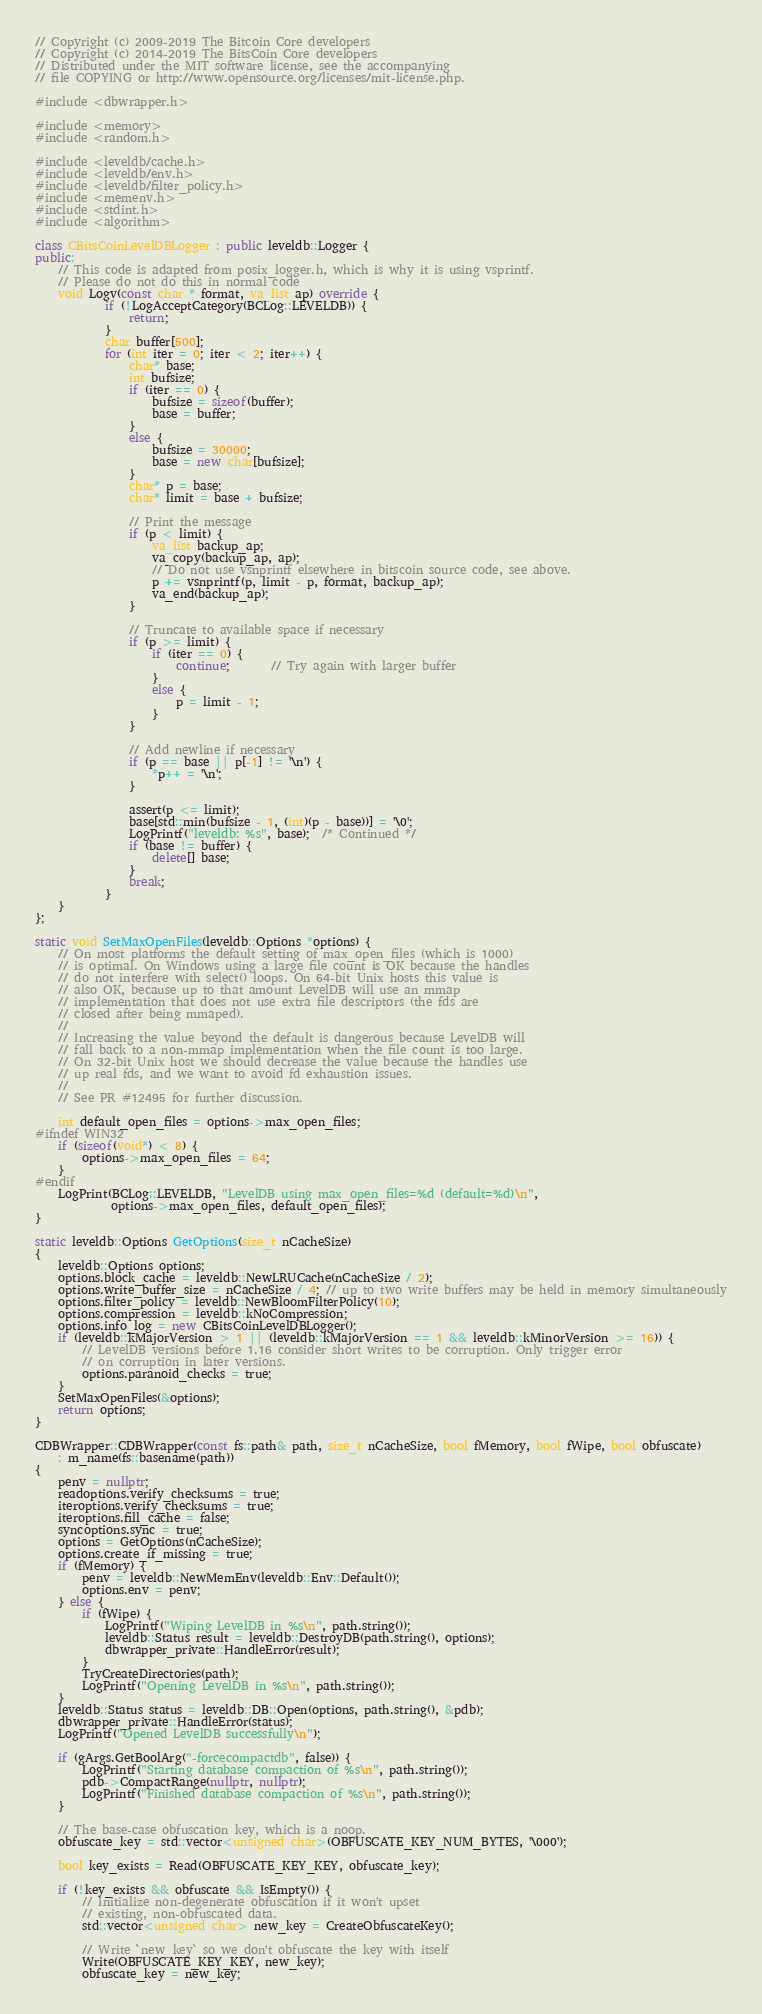Convert code to text. <code><loc_0><loc_0><loc_500><loc_500><_C++_>// Copyright (c) 2009-2019 The Bitcoin Core developers
// Copyright (c) 2014-2019 The BitsCoin Core developers
// Distributed under the MIT software license, see the accompanying
// file COPYING or http://www.opensource.org/licenses/mit-license.php.

#include <dbwrapper.h>

#include <memory>
#include <random.h>

#include <leveldb/cache.h>
#include <leveldb/env.h>
#include <leveldb/filter_policy.h>
#include <memenv.h>
#include <stdint.h>
#include <algorithm>

class CBitsCoinLevelDBLogger : public leveldb::Logger {
public:
    // This code is adapted from posix_logger.h, which is why it is using vsprintf.
    // Please do not do this in normal code
    void Logv(const char * format, va_list ap) override {
            if (!LogAcceptCategory(BCLog::LEVELDB)) {
                return;
            }
            char buffer[500];
            for (int iter = 0; iter < 2; iter++) {
                char* base;
                int bufsize;
                if (iter == 0) {
                    bufsize = sizeof(buffer);
                    base = buffer;
                }
                else {
                    bufsize = 30000;
                    base = new char[bufsize];
                }
                char* p = base;
                char* limit = base + bufsize;

                // Print the message
                if (p < limit) {
                    va_list backup_ap;
                    va_copy(backup_ap, ap);
                    // Do not use vsnprintf elsewhere in bitscoin source code, see above.
                    p += vsnprintf(p, limit - p, format, backup_ap);
                    va_end(backup_ap);
                }

                // Truncate to available space if necessary
                if (p >= limit) {
                    if (iter == 0) {
                        continue;       // Try again with larger buffer
                    }
                    else {
                        p = limit - 1;
                    }
                }

                // Add newline if necessary
                if (p == base || p[-1] != '\n') {
                    *p++ = '\n';
                }

                assert(p <= limit);
                base[std::min(bufsize - 1, (int)(p - base))] = '\0';
                LogPrintf("leveldb: %s", base);  /* Continued */
                if (base != buffer) {
                    delete[] base;
                }
                break;
            }
    }
};

static void SetMaxOpenFiles(leveldb::Options *options) {
    // On most platforms the default setting of max_open_files (which is 1000)
    // is optimal. On Windows using a large file count is OK because the handles
    // do not interfere with select() loops. On 64-bit Unix hosts this value is
    // also OK, because up to that amount LevelDB will use an mmap
    // implementation that does not use extra file descriptors (the fds are
    // closed after being mmaped).
    //
    // Increasing the value beyond the default is dangerous because LevelDB will
    // fall back to a non-mmap implementation when the file count is too large.
    // On 32-bit Unix host we should decrease the value because the handles use
    // up real fds, and we want to avoid fd exhaustion issues.
    //
    // See PR #12495 for further discussion.

    int default_open_files = options->max_open_files;
#ifndef WIN32
    if (sizeof(void*) < 8) {
        options->max_open_files = 64;
    }
#endif
    LogPrint(BCLog::LEVELDB, "LevelDB using max_open_files=%d (default=%d)\n",
             options->max_open_files, default_open_files);
}

static leveldb::Options GetOptions(size_t nCacheSize)
{
    leveldb::Options options;
    options.block_cache = leveldb::NewLRUCache(nCacheSize / 2);
    options.write_buffer_size = nCacheSize / 4; // up to two write buffers may be held in memory simultaneously
    options.filter_policy = leveldb::NewBloomFilterPolicy(10);
    options.compression = leveldb::kNoCompression;
    options.info_log = new CBitsCoinLevelDBLogger();
    if (leveldb::kMajorVersion > 1 || (leveldb::kMajorVersion == 1 && leveldb::kMinorVersion >= 16)) {
        // LevelDB versions before 1.16 consider short writes to be corruption. Only trigger error
        // on corruption in later versions.
        options.paranoid_checks = true;
    }
    SetMaxOpenFiles(&options);
    return options;
}

CDBWrapper::CDBWrapper(const fs::path& path, size_t nCacheSize, bool fMemory, bool fWipe, bool obfuscate)
    : m_name(fs::basename(path))
{
    penv = nullptr;
    readoptions.verify_checksums = true;
    iteroptions.verify_checksums = true;
    iteroptions.fill_cache = false;
    syncoptions.sync = true;
    options = GetOptions(nCacheSize);
    options.create_if_missing = true;
    if (fMemory) {
        penv = leveldb::NewMemEnv(leveldb::Env::Default());
        options.env = penv;
    } else {
        if (fWipe) {
            LogPrintf("Wiping LevelDB in %s\n", path.string());
            leveldb::Status result = leveldb::DestroyDB(path.string(), options);
            dbwrapper_private::HandleError(result);
        }
        TryCreateDirectories(path);
        LogPrintf("Opening LevelDB in %s\n", path.string());
    }
    leveldb::Status status = leveldb::DB::Open(options, path.string(), &pdb);
    dbwrapper_private::HandleError(status);
    LogPrintf("Opened LevelDB successfully\n");

    if (gArgs.GetBoolArg("-forcecompactdb", false)) {
        LogPrintf("Starting database compaction of %s\n", path.string());
        pdb->CompactRange(nullptr, nullptr);
        LogPrintf("Finished database compaction of %s\n", path.string());
    }

    // The base-case obfuscation key, which is a noop.
    obfuscate_key = std::vector<unsigned char>(OBFUSCATE_KEY_NUM_BYTES, '\000');

    bool key_exists = Read(OBFUSCATE_KEY_KEY, obfuscate_key);

    if (!key_exists && obfuscate && IsEmpty()) {
        // Initialize non-degenerate obfuscation if it won't upset
        // existing, non-obfuscated data.
        std::vector<unsigned char> new_key = CreateObfuscateKey();

        // Write `new_key` so we don't obfuscate the key with itself
        Write(OBFUSCATE_KEY_KEY, new_key);
        obfuscate_key = new_key;
</code> 